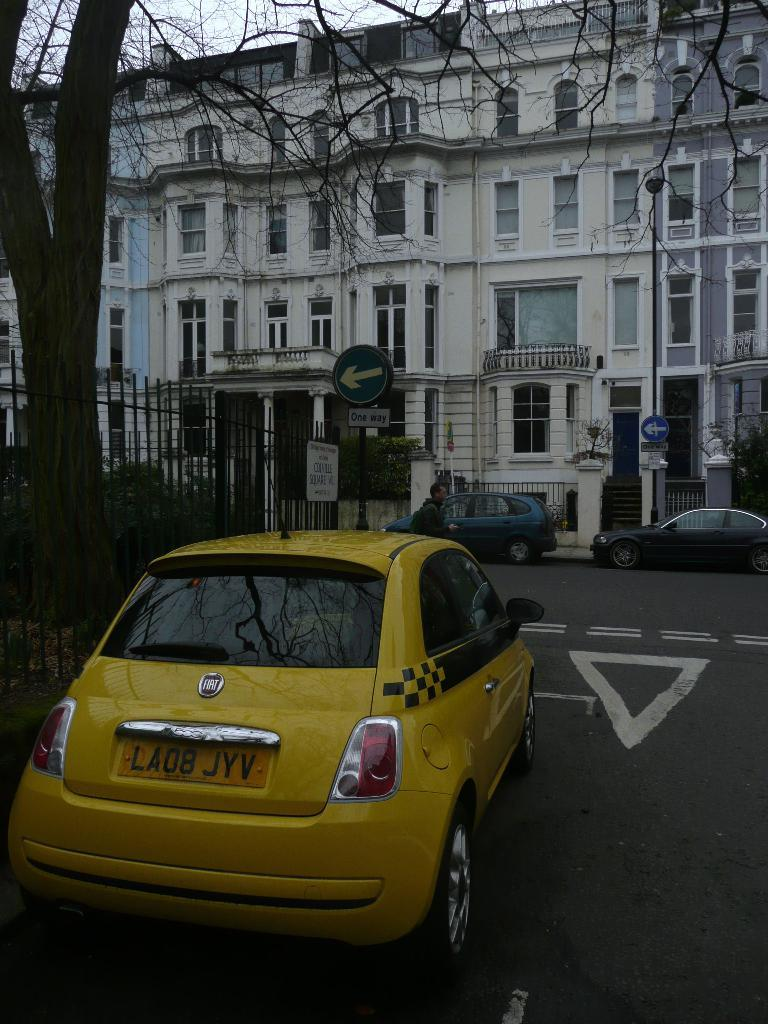Provide a one-sentence caption for the provided image. A yellow taxi cab has LA08 JYV for a license plate number. 